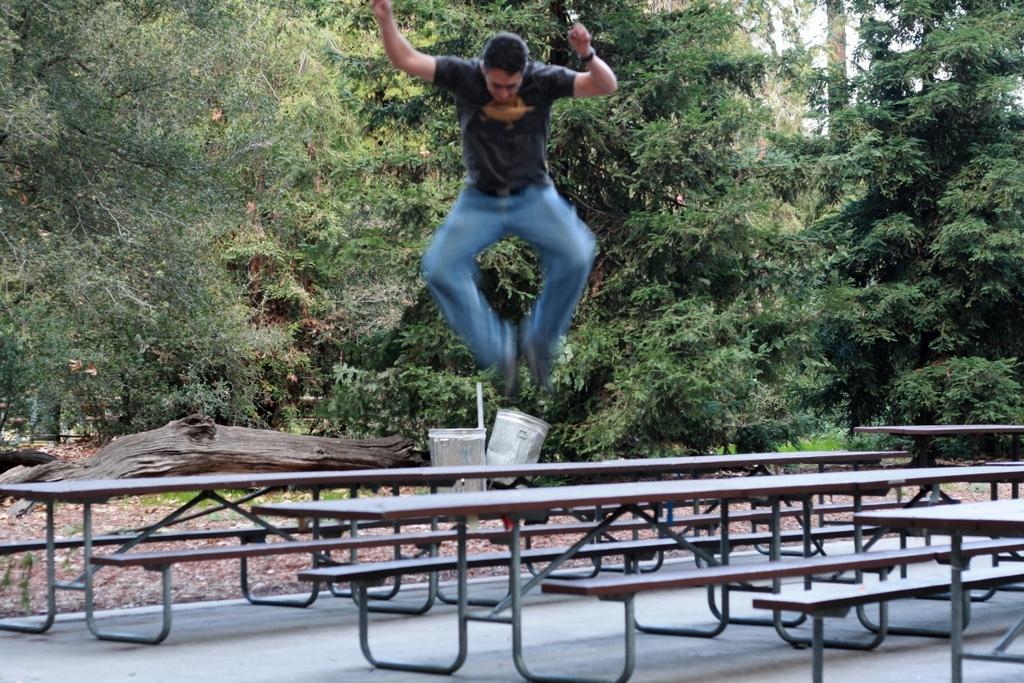Could you give a brief overview of what you see in this image? In this image, there is an outside view. There is a person in the middle of the image wearing clothes and jumping on the table. There are some tables at the bottom of the image. In the background of the image, there are some trees. 